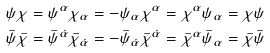Convert formula to latex. <formula><loc_0><loc_0><loc_500><loc_500>\psi \chi = \psi ^ { \alpha } \chi _ { \alpha } = - \psi _ { \alpha } \chi ^ { \alpha } = \chi ^ { \alpha } \psi _ { \alpha } = \chi \psi \\ \bar { \psi } \bar { \chi } = \bar { \psi } ^ { \dot { \alpha } } \bar { \chi } _ { \dot { \alpha } } = - \bar { \psi } _ { \dot { \alpha } } \bar { \chi } ^ { \dot { \alpha } } = \bar { \chi } ^ { \alpha } \bar { \psi } _ { \alpha } = \bar { \chi } \bar { \psi }</formula> 